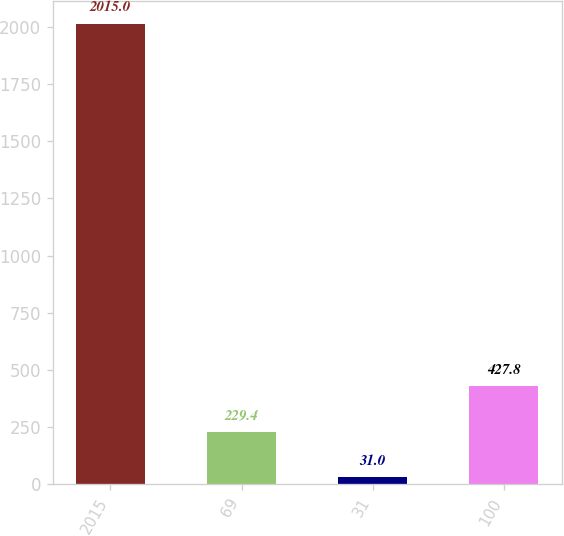Convert chart. <chart><loc_0><loc_0><loc_500><loc_500><bar_chart><fcel>2015<fcel>69<fcel>31<fcel>100<nl><fcel>2015<fcel>229.4<fcel>31<fcel>427.8<nl></chart> 